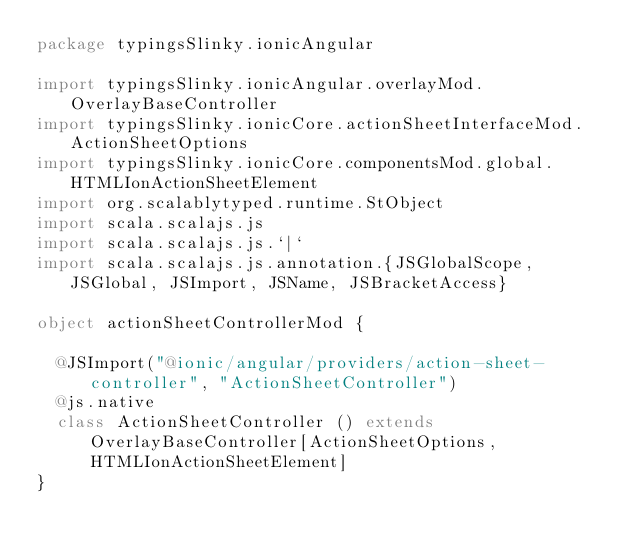Convert code to text. <code><loc_0><loc_0><loc_500><loc_500><_Scala_>package typingsSlinky.ionicAngular

import typingsSlinky.ionicAngular.overlayMod.OverlayBaseController
import typingsSlinky.ionicCore.actionSheetInterfaceMod.ActionSheetOptions
import typingsSlinky.ionicCore.componentsMod.global.HTMLIonActionSheetElement
import org.scalablytyped.runtime.StObject
import scala.scalajs.js
import scala.scalajs.js.`|`
import scala.scalajs.js.annotation.{JSGlobalScope, JSGlobal, JSImport, JSName, JSBracketAccess}

object actionSheetControllerMod {
  
  @JSImport("@ionic/angular/providers/action-sheet-controller", "ActionSheetController")
  @js.native
  class ActionSheetController () extends OverlayBaseController[ActionSheetOptions, HTMLIonActionSheetElement]
}
</code> 